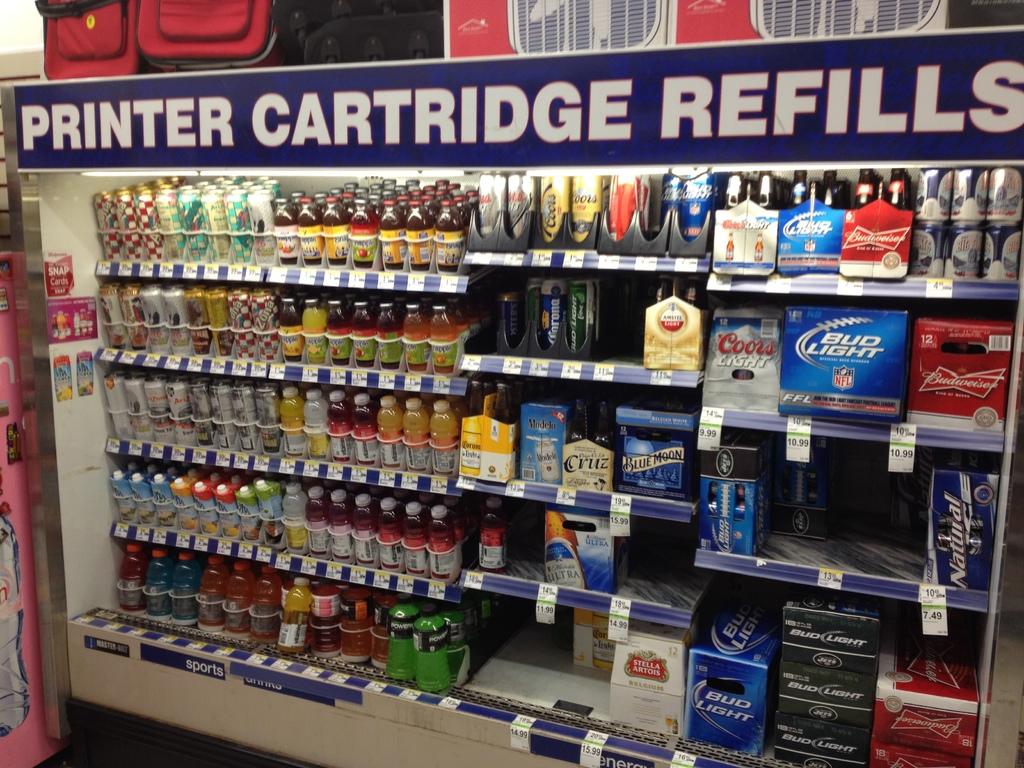What brands of drinks are being sold here?
Keep it short and to the point. Beer. What kind of refills are advertised?
Make the answer very short. Printer cartridge. 